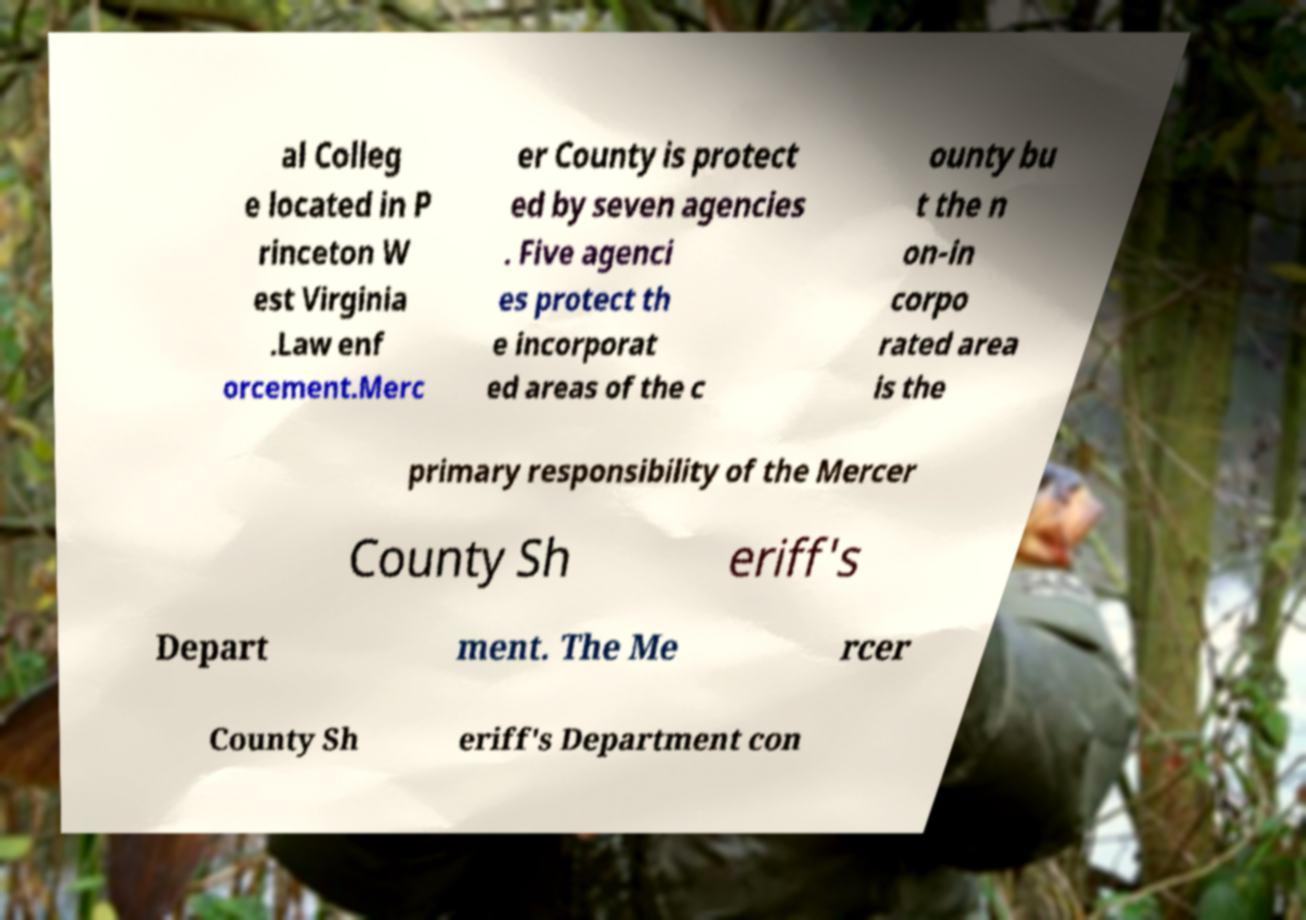There's text embedded in this image that I need extracted. Can you transcribe it verbatim? al Colleg e located in P rinceton W est Virginia .Law enf orcement.Merc er County is protect ed by seven agencies . Five agenci es protect th e incorporat ed areas of the c ounty bu t the n on-in corpo rated area is the primary responsibility of the Mercer County Sh eriff's Depart ment. The Me rcer County Sh eriff's Department con 